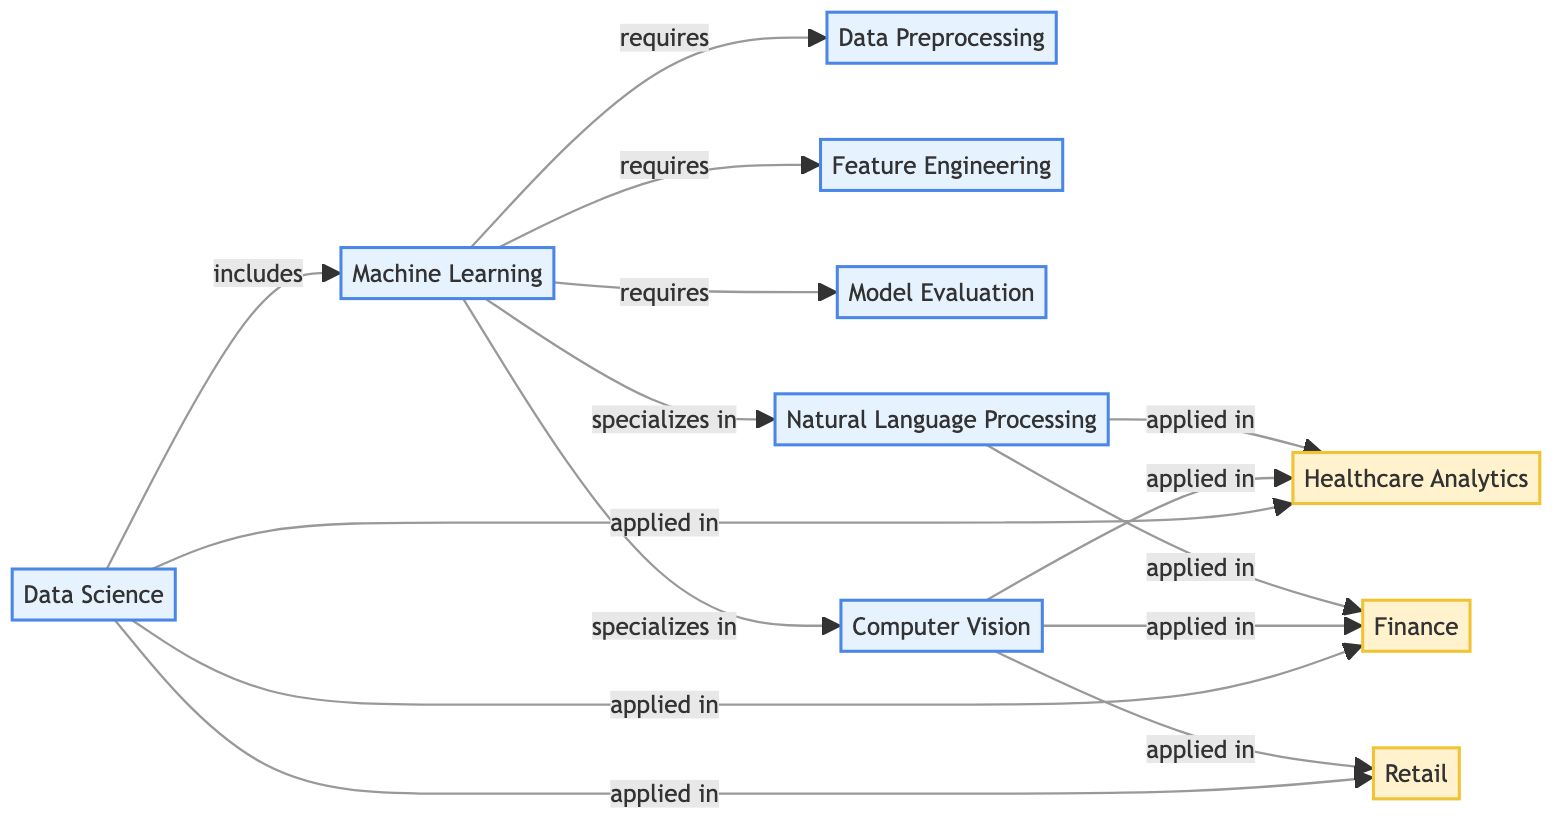What is the total number of nodes in the diagram? The diagram lists 10 distinct concepts and applications, which are represented as nodes. Counting them gives a total of 10 nodes.
Answer: 10 What relationship links "Data Science" and "Machine Learning"? According to the diagram, the edge connecting "Data Science" and "Machine Learning" is labeled "includes". This shows that Machine Learning is a component of Data Science.
Answer: includes How many applications are directly connected to "Natural Language Processing"? The diagram shows that "Natural Language Processing" is applied in "Healthcare Analytics" and "Finance". Therefore, there are 2 direct applications connected to it.
Answer: 2 Which node describes the relationship between "Machine Learning" and "Model Evaluation"? The edge connecting "Machine Learning" and "Model Evaluation" is labeled "requires", indicating that Model Evaluation is a necessary component of Machine Learning.
Answer: requires In how many areas is "Computer Vision" applied according to the diagram? The diagram indicates that "Computer Vision" is applied in "Healthcare Analytics", "Finance", and "Retail". Counting these gives a total of 3 areas of application.
Answer: 3 What is the main node from which all applications stem? The node "Data Science" is connected to all applications in the diagram, indicating it is the primary source for these applications.
Answer: Data Science Which concept is specialized in among "Data Science" connections? The diagram shows two edges from "Machine Learning" labeled "specializes in", which are "Natural Language Processing" and "Computer Vision". This indicates that Machine Learning has a specialization focus in these two areas.
Answer: Natural Language Processing, Computer Vision How many edges connect to "Feature Engineering"? "Feature Engineering" receives a single direct connection from "Machine Learning", indicating it has 1 edge linked to it in the diagram.
Answer: 1 What type of relationship exists between "Natural Language Processing" and "Healthcare Analytics"? The relationship indicated in the diagram is labeled "applied in", meaning that Natural Language Processing finds its practical use within Healthcare Analytics.
Answer: applied in 